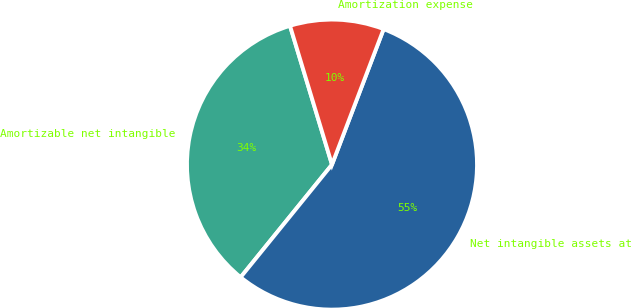Convert chart to OTSL. <chart><loc_0><loc_0><loc_500><loc_500><pie_chart><fcel>Amortizable net intangible<fcel>Net intangible assets at<fcel>Amortization expense<nl><fcel>34.48%<fcel>55.05%<fcel>10.47%<nl></chart> 